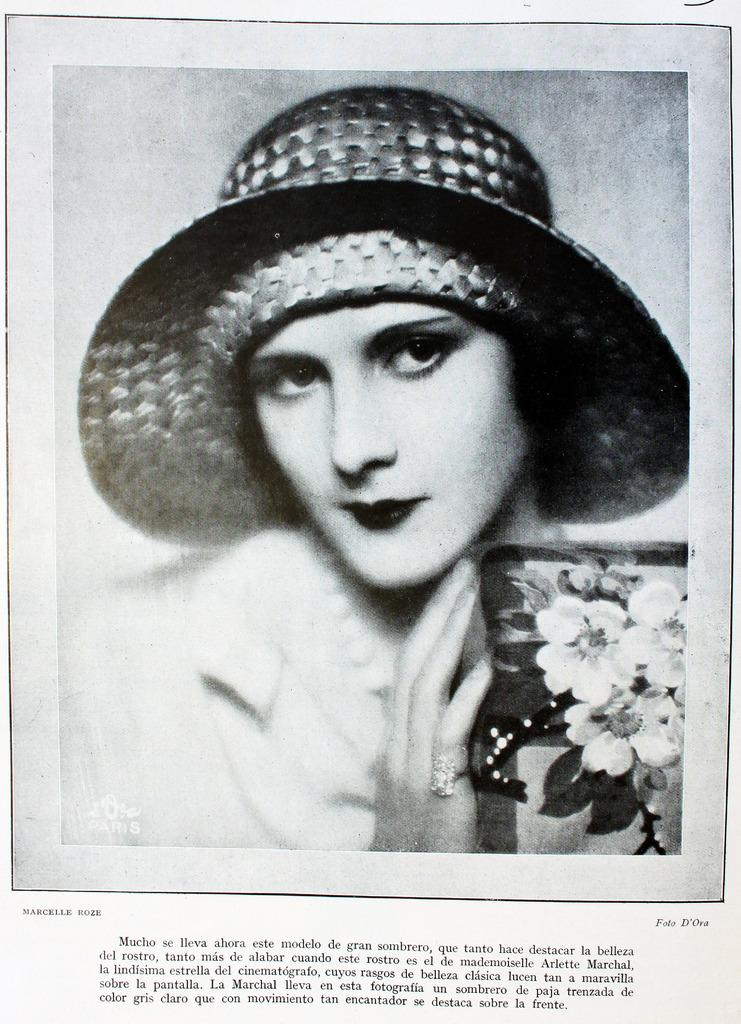What is the color scheme of the image? The image is black and white. Can you describe the person in the image? There is a lady in the image. What is the lady wearing on her head? The lady is wearing a hat. What is the lady holding in the image? The lady is holding an item with flowers. Is there any text present in the image? Yes, there is text written on the image. Can you tell me what type of quartz is present in the image? There is no quartz present in the image. What kind of monkey can be seen interacting with the lady in the image? There is no monkey present in the image; it only features a lady wearing a hat and holding an item with flowers. 